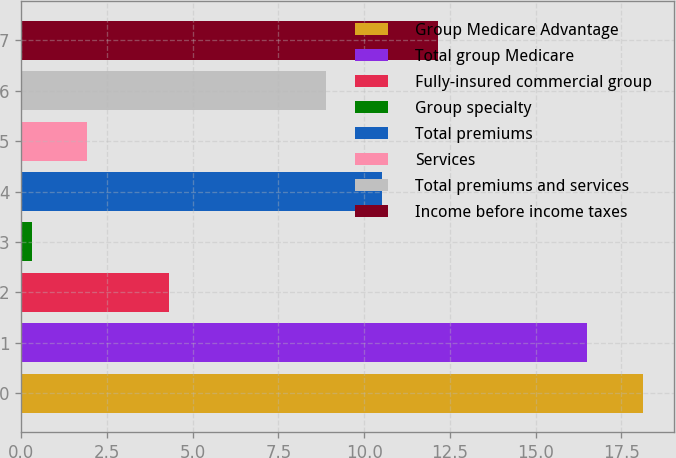Convert chart. <chart><loc_0><loc_0><loc_500><loc_500><bar_chart><fcel>Group Medicare Advantage<fcel>Total group Medicare<fcel>Fully-insured commercial group<fcel>Group specialty<fcel>Total premiums<fcel>Services<fcel>Total premiums and services<fcel>Income before income taxes<nl><fcel>18.13<fcel>16.5<fcel>4.3<fcel>0.3<fcel>10.53<fcel>1.93<fcel>8.9<fcel>12.16<nl></chart> 